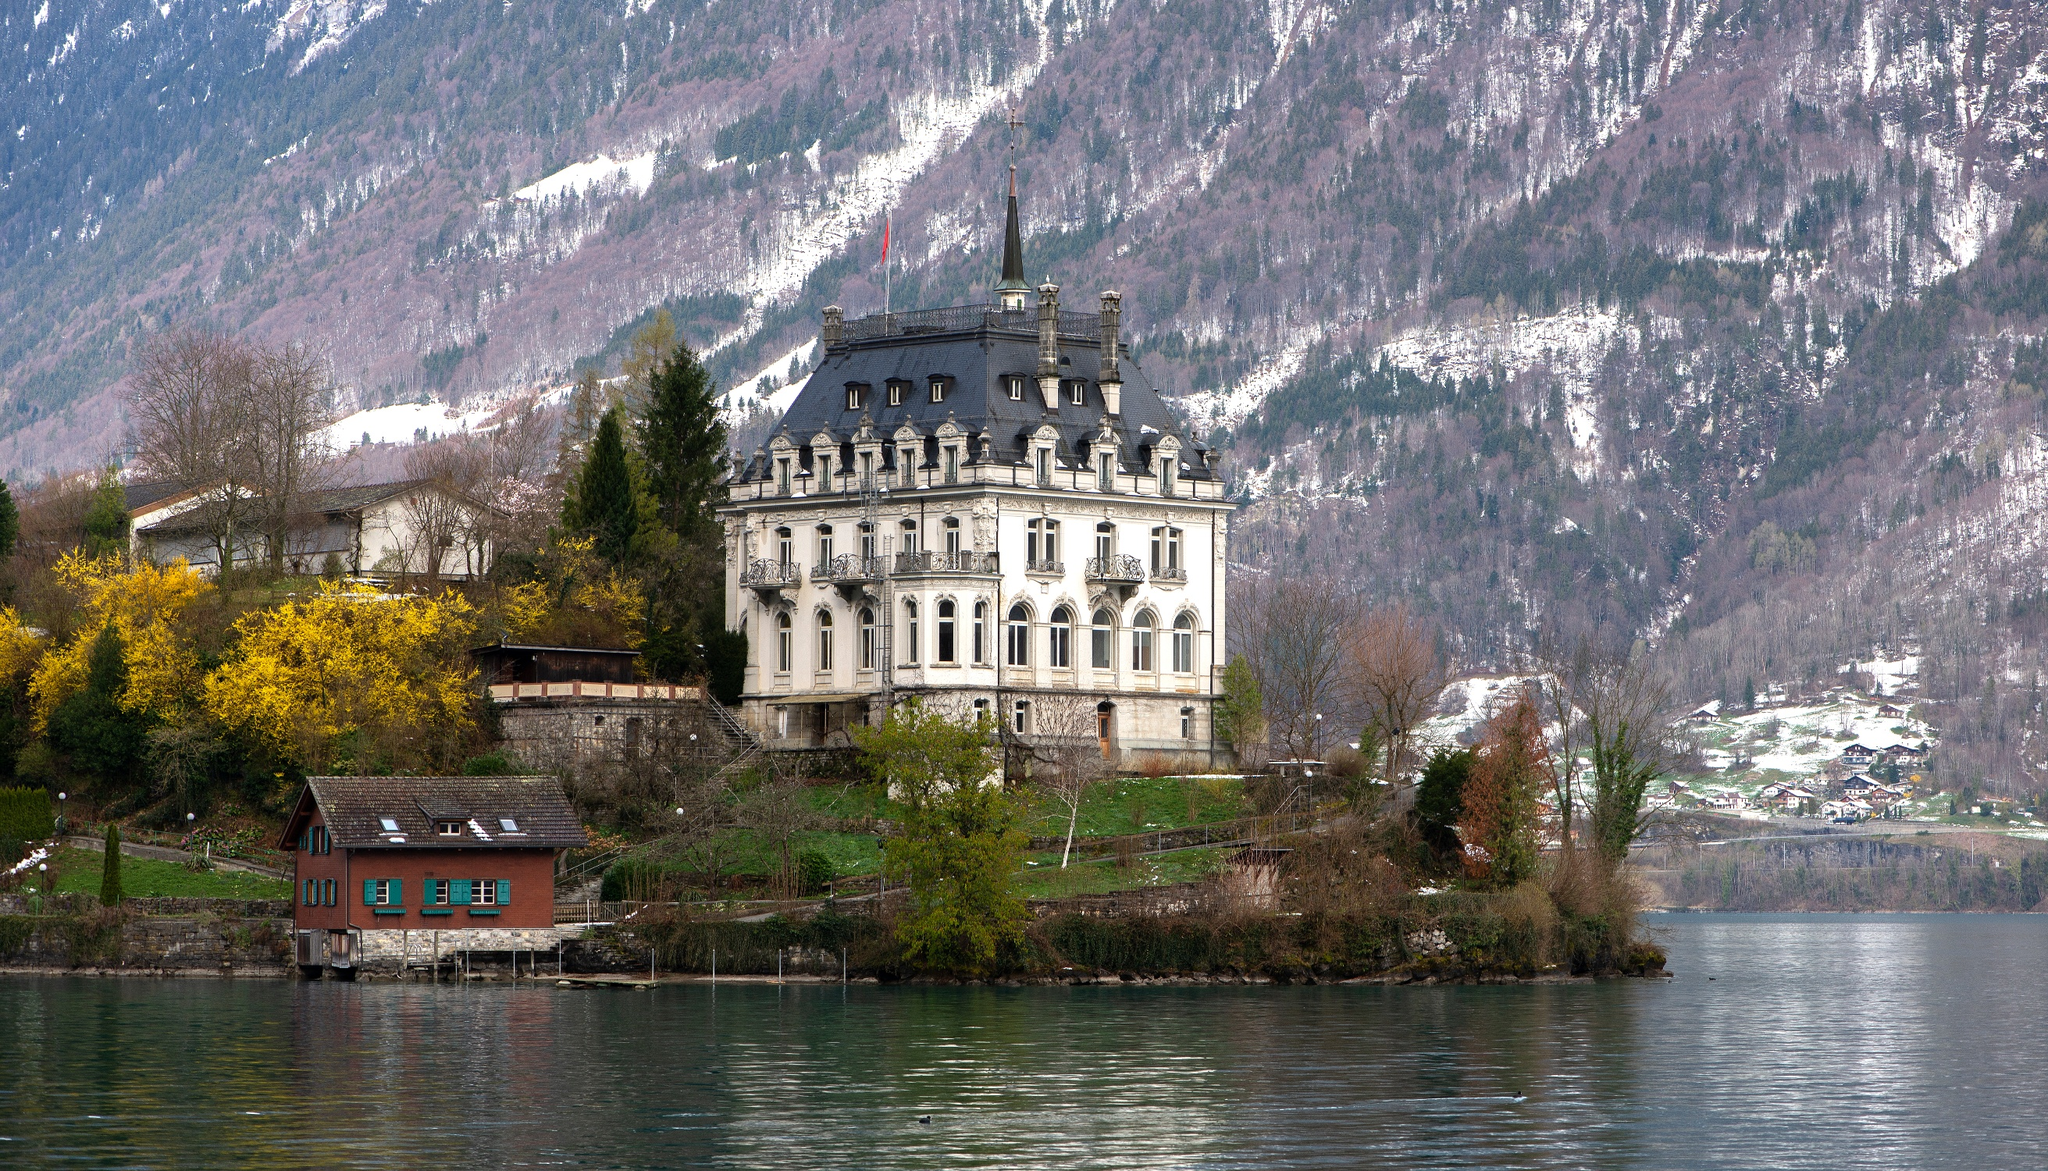What might the future hold for such a historic place? The future of Iseltwald Castle is likely to be as illustrious as its past. Preserved as a heritage site, it will continue to attract visitors who appreciate history and natural beauty. It may evolve into a cultural center, hosting art exhibitions, classical concerts, weddings, and other significant events. Advanced restoration projects might ensure that its architectural splendor is maintained for future generations. The surrounding area may also develop with sustainable tourism in mind, offering eco-friendly accommodations and activities, ensuring that the natural beauty of Lake Brienz and the Swiss landscape are preserved while making the castle a vibrant part of the community and a symbol of enduring heritage. Describe a short, realistic scenario that could take place here. A visitor stands at the edge of Lake Brienz, snapping photos of the stunning Iseltwald Castle. They’re joined by a local guide who shares fascinating stories about the castle’s history. As they stroll through the well-maintained grounds, they come across a group of artists capturing the landscape on canvas. The visitor feels a deep sense of connection to the past, and a profound appreciation for the beauty that surrounds them. Describe a long, realistic scenario that could take place here. A family decides to spend a weekend at Iseltwald Castle. They set off early in the morning, taking a scenic drive along the lake before arriving at the castle. The parents are history enthusiasts, while the children are excited to explore the ‘real-life castle’ they’ve read about. After checking into a charming nearby inn, they join a guided tour of the castle. Enraptured by tales from the guide, they learn about the noble families who lived there, the architecture, and the cultural significance of the site. In the afternoon, they enjoy a boat ride on Lake Brienz, taking in the spectacular views of the castle from the water. Returning to the castle grounds, they set up a picnic amidst blooming flower beds. The parents relax and read more about the castle’s history while the children play and pretend to be knights and princesses. As the sun sets, they decide to have dinner at a quaint lakeside restaurant, savoring local Swiss cuisine. The day concludes with a twilight walk along the lake, where singing birds and the rustle of leaves add to the serene ambiance. They leave with cameras full of memories and a shared experience they will cherish forever. 